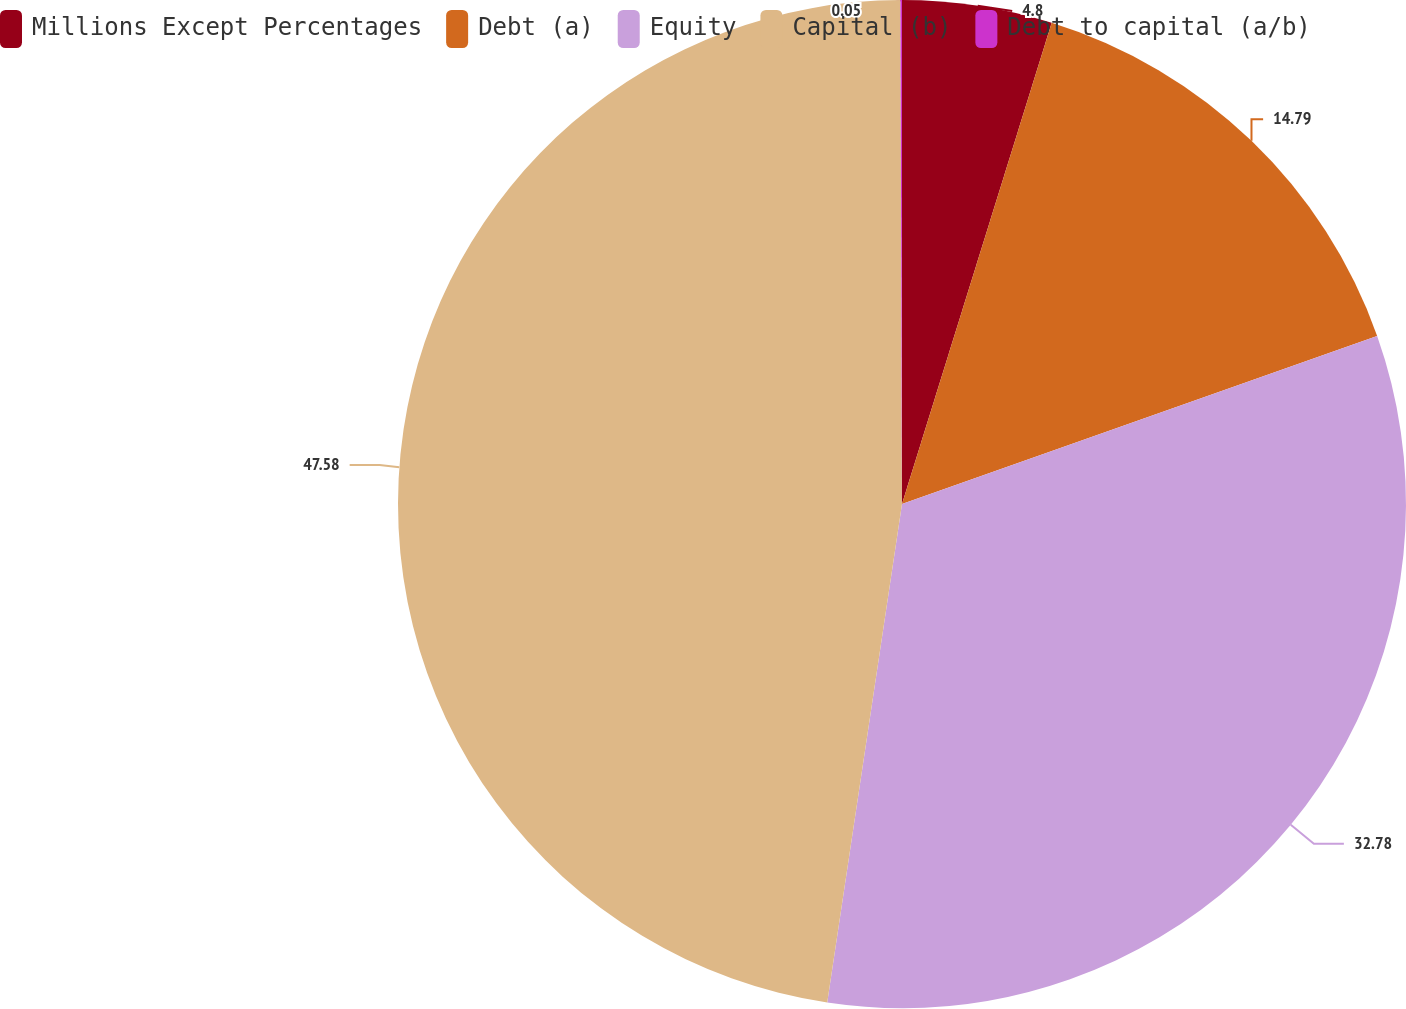Convert chart. <chart><loc_0><loc_0><loc_500><loc_500><pie_chart><fcel>Millions Except Percentages<fcel>Debt (a)<fcel>Equity<fcel>Capital (b)<fcel>Debt to capital (a/b)<nl><fcel>4.8%<fcel>14.79%<fcel>32.78%<fcel>47.58%<fcel>0.05%<nl></chart> 